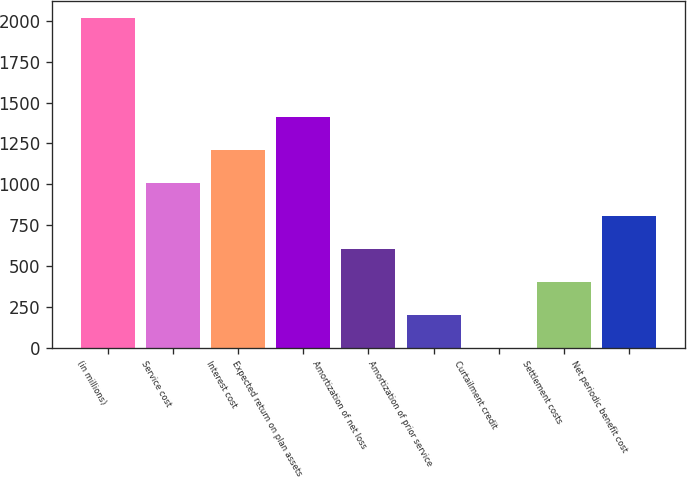Convert chart. <chart><loc_0><loc_0><loc_500><loc_500><bar_chart><fcel>(in millions)<fcel>Service cost<fcel>Interest cost<fcel>Expected return on plan assets<fcel>Amortization of net loss<fcel>Amortization of prior service<fcel>Curtailment credit<fcel>Settlement costs<fcel>Net periodic benefit cost<nl><fcel>2019<fcel>1009.55<fcel>1211.44<fcel>1413.33<fcel>605.77<fcel>201.99<fcel>0.1<fcel>403.88<fcel>807.66<nl></chart> 